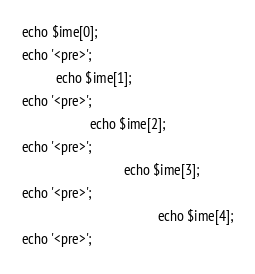<code> <loc_0><loc_0><loc_500><loc_500><_PHP_>echo $ime[0];
echo '<pre>';
          echo $ime[1];
echo '<pre>';
                    echo $ime[2];
echo '<pre>';
                              echo $ime[3];
echo '<pre>';
                                        echo $ime[4];
echo '<pre>';
</code> 